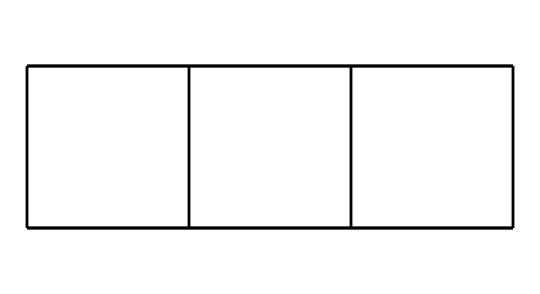What is the name of this compound? The SMILES representation corresponds to cubane, which is a well-known cage hydrocarbon characterized by its cubical structure.
Answer: cubane How many carbon atoms are present in the structure? Analyzing the SMILES code, each 'C' represents a carbon atom. There are a total of 8 'C's in the representation.
Answer: 8 What type of structure does this molecule present? The visual representation indicates a highly symmetrical 3-dimensional structure with the carbon atoms arranged in a cubic geometry, typical of a cage compound.
Answer: cage How many hydrogen atoms are bonded to the carbon atoms in cubane? For every carbon atom in cubane, there are 2 additional hydrogen atoms hydrating each carbon, leading to the formula C8H8. Thus, there are 8 hydrogen atoms connected to the carbon atoms.
Answer: 8 Is this molecule stable under normal conditions? Cubane is known to be relatively unstable when exposed to heat or pressure, due to its angle strain from the bond angles deviating from the ideal tetrahedral angle.
Answer: no What is the bond angle between the carbon atoms in cubane? Due to the geometry of cubane being cubic, the carbon-carbon bond angles are approximately 90 degrees, which is indicative of significant strain in the structure.
Answer: 90 degrees Can this compound be classified as a saturated or unsaturated hydrocarbon? Since all carbon atoms in cubane are fully bonded to hydrogen atoms with no double or triple bonds, it is classified as a saturated hydrocarbon.
Answer: saturated 